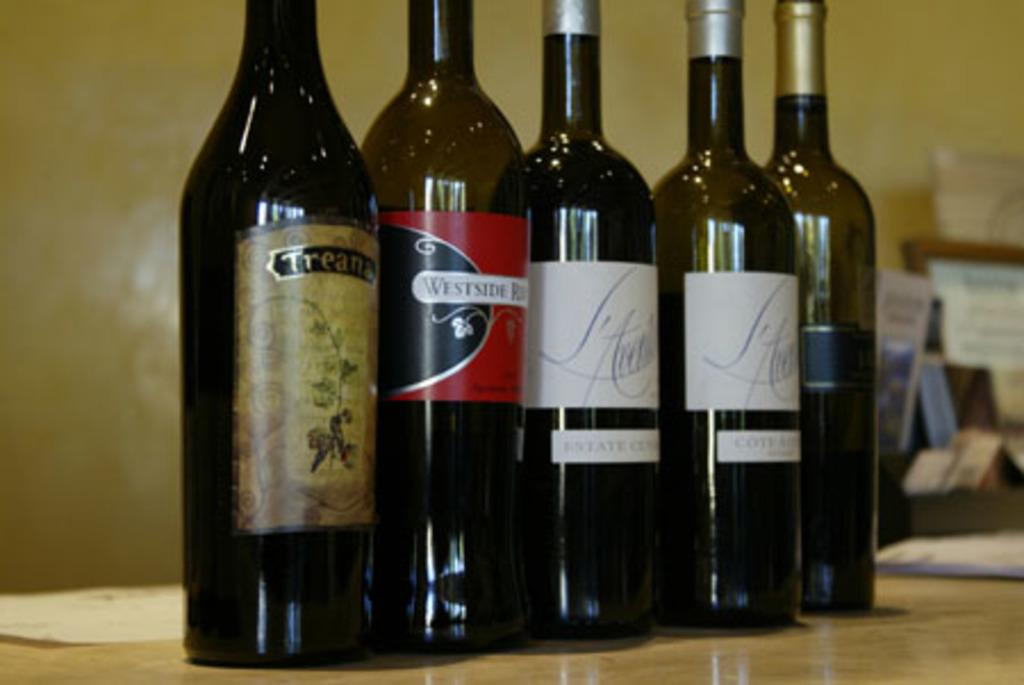Provide a one-sentence caption for the provided image. A tall bottle of Westside sits among a row of wines. 